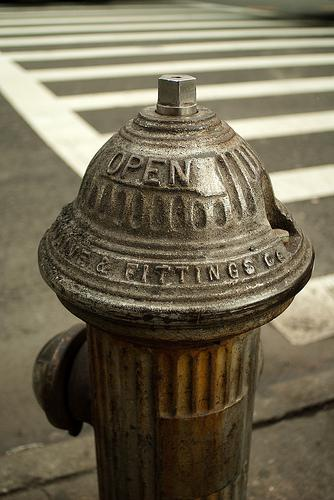Question: what is the object sitting on?
Choices:
A. Fence.
B. Street.
C. Bench.
D. Sidewalk.
Answer with the letter. Answer: D Question: where do you open a valve at?
Choices:
A. Bottom.
B. Top.
C. On the left.
D. On the right.
Answer with the letter. Answer: B 